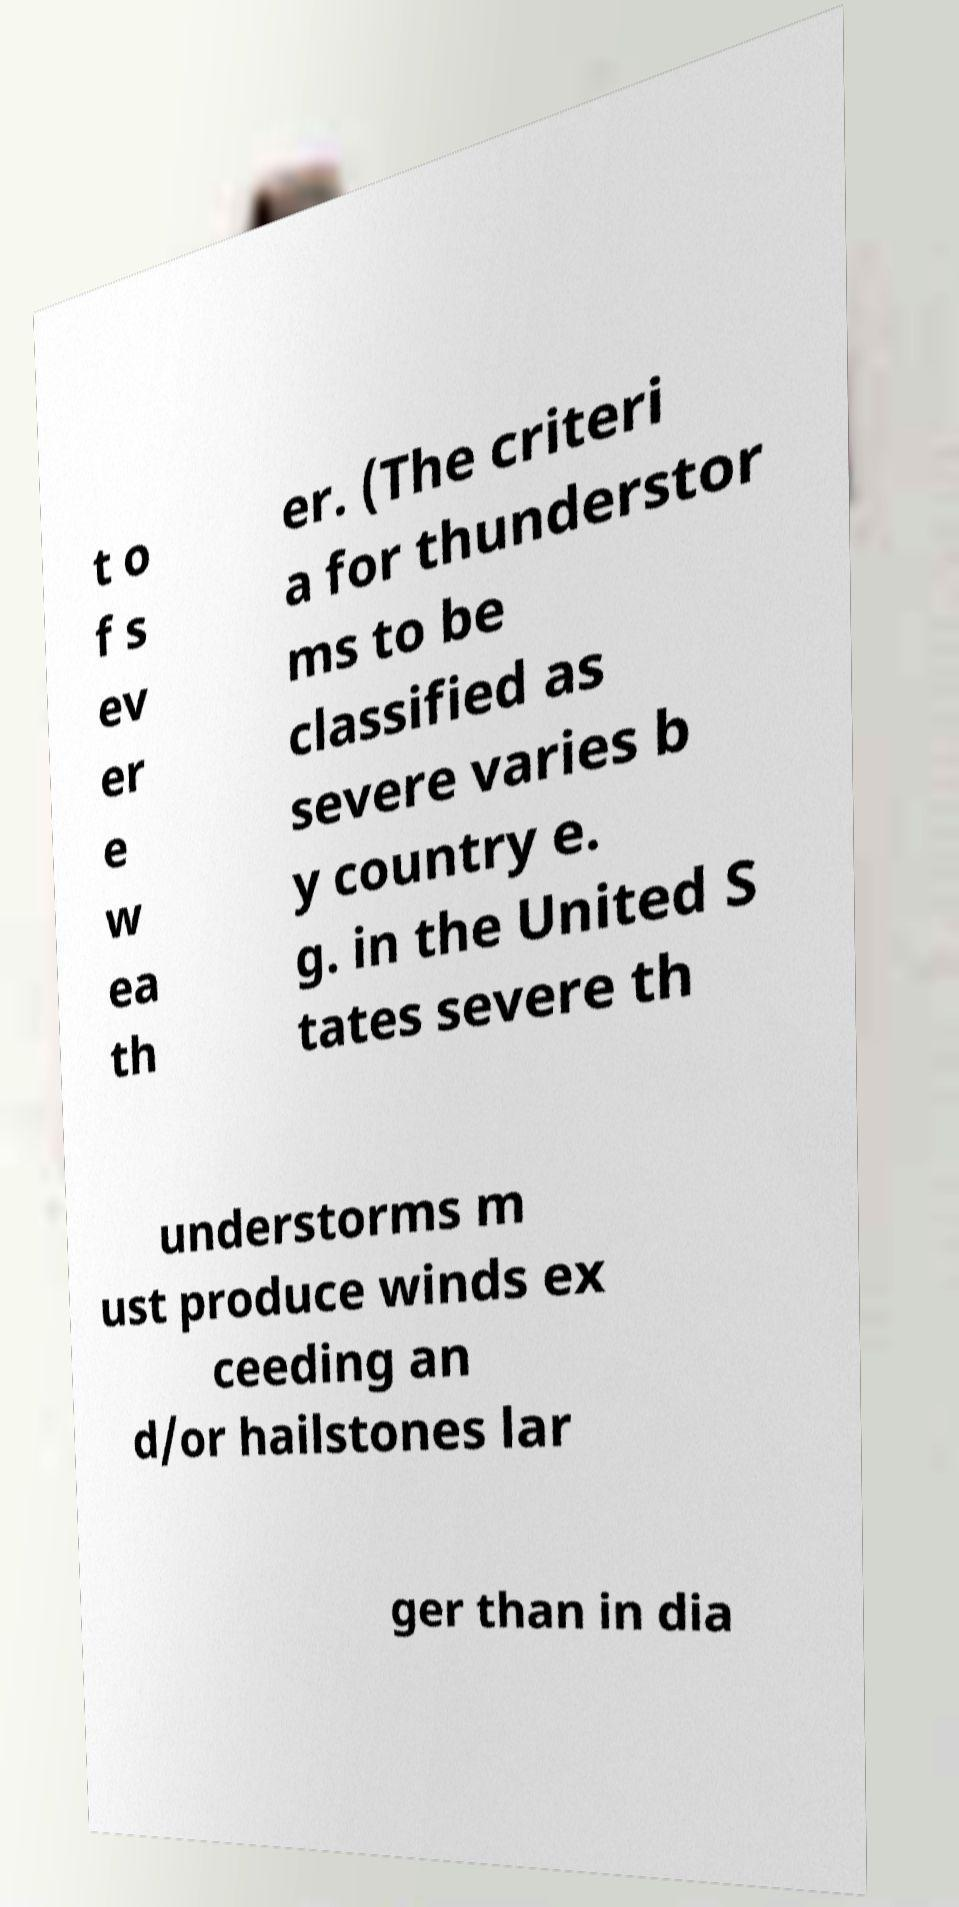What messages or text are displayed in this image? I need them in a readable, typed format. t o f s ev er e w ea th er. (The criteri a for thunderstor ms to be classified as severe varies b y country e. g. in the United S tates severe th understorms m ust produce winds ex ceeding an d/or hailstones lar ger than in dia 